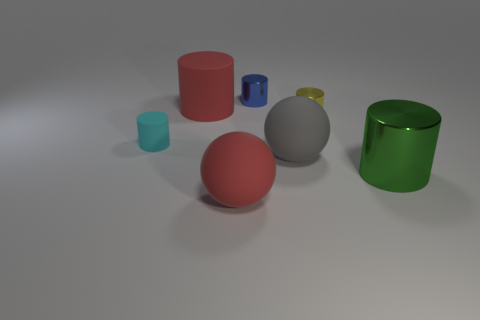There is a object that is on the right side of the gray object and behind the green metal thing; what shape is it?
Your answer should be compact. Cylinder. The metal object that is left of the large rubber object to the right of the large rubber ball that is in front of the green metallic cylinder is what color?
Your answer should be compact. Blue. Is the number of tiny blue metal cylinders that are right of the tiny blue cylinder less than the number of blue shiny cylinders?
Offer a terse response. Yes. Is the shape of the small thing to the right of the blue shiny cylinder the same as the blue object that is on the right side of the cyan object?
Your response must be concise. Yes. What number of objects are rubber things that are on the left side of the big gray sphere or red spheres?
Your answer should be very brief. 3. There is a large thing that is the same color as the big matte cylinder; what is it made of?
Provide a succinct answer. Rubber. Is there a big red matte thing that is left of the large red rubber thing in front of the shiny cylinder that is on the right side of the tiny yellow cylinder?
Make the answer very short. Yes. Is the number of blue metallic cylinders that are on the left side of the small blue metal cylinder less than the number of large cylinders that are in front of the gray object?
Your response must be concise. Yes. What color is the other large sphere that is the same material as the big gray ball?
Your answer should be compact. Red. There is a rubber cylinder on the right side of the tiny cyan thing that is on the left side of the green shiny object; what is its color?
Provide a short and direct response. Red. 